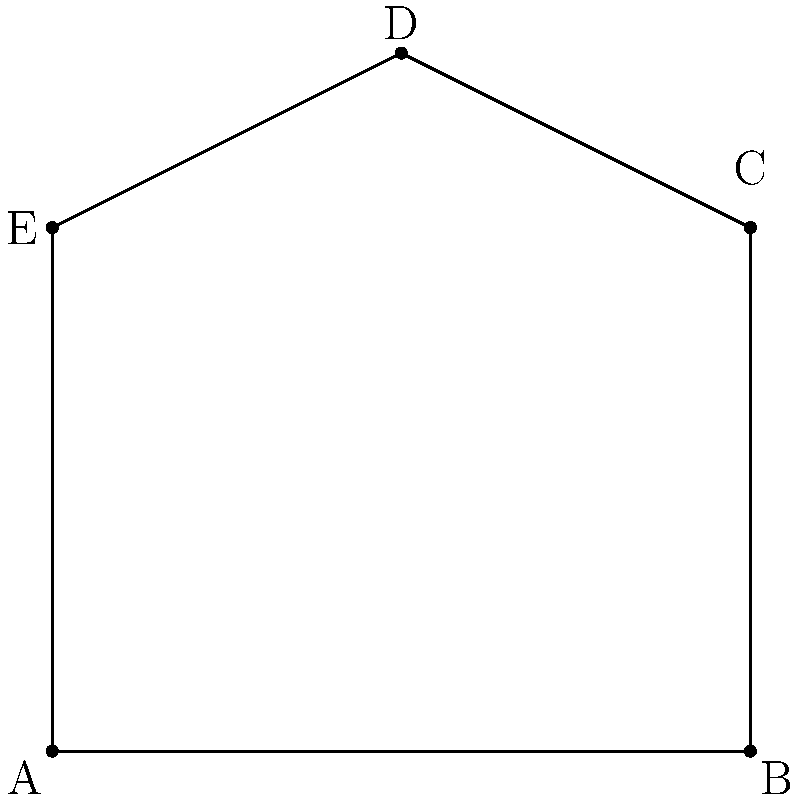Given the polygon ABCDE with vertices A(0,0), B(4,0), C(4,3), D(2,4), and E(0,3), calculate its area using the Shoelace formula. Round your answer to two decimal places. How might this calculation help identify potential bugs in a polygon area algorithm? To calculate the area of the polygon using the Shoelace formula, we'll follow these steps:

1) The Shoelace formula for a polygon with vertices $(x_1, y_1), (x_2, y_2), ..., (x_n, y_n)$ is:

   $$Area = \frac{1}{2}|(x_1y_2 + x_2y_3 + ... + x_ny_1) - (y_1x_2 + y_2x_3 + ... + y_nx_1)|$$

2) Let's organize our vertices:
   A(0,0), B(4,0), C(4,3), D(2,4), E(0,3)

3) Now, let's apply the formula:

   $$\begin{align*}
   Area &= \frac{1}{2}|(0\cdot0 + 4\cdot3 + 4\cdot4 + 2\cdot3 + 0\cdot0) - (0\cdot4 + 0\cdot4 + 3\cdot2 + 4\cdot0 + 3\cdot0)|\\
   &= \frac{1}{2}|(0 + 12 + 16 + 6 + 0) - (0 + 0 + 6 + 0 + 0)|\\
   &= \frac{1}{2}|34 - 6|\\
   &= \frac{1}{2}(28)\\
   &= 14
   \end{align*}$$

4) The area is 14 square units.

This calculation can help identify potential bugs in a polygon area algorithm by:

1. Providing a known correct result for comparison.
2. Allowing for edge case testing (e.g., concave polygons, self-intersecting polygons).
3. Highlighting potential issues with precision in floating-point calculations.
4. Demonstrating the importance of vertex order in calculations.

By understanding these potential pitfalls, data science students can develop more robust and accurate algorithms for geometric calculations.
Answer: 14 square units 